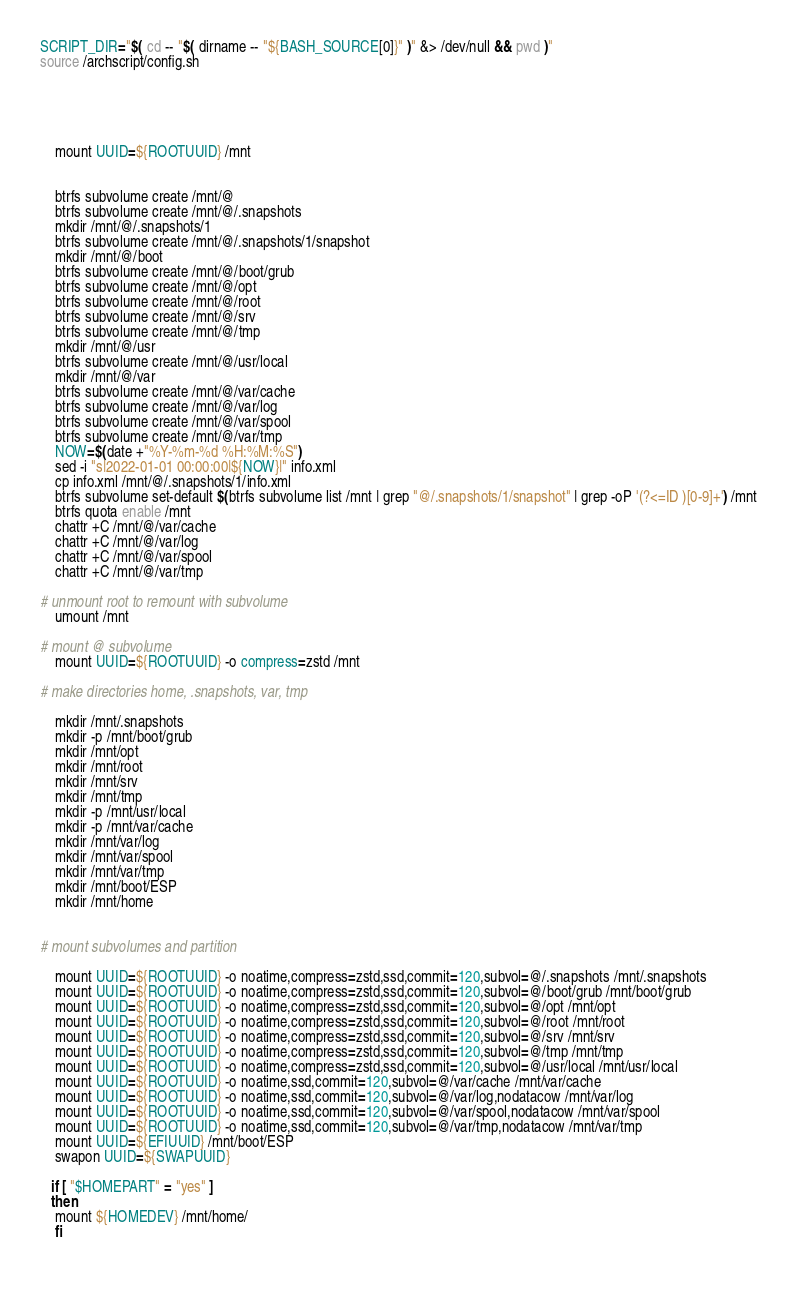<code> <loc_0><loc_0><loc_500><loc_500><_Bash_>SCRIPT_DIR="$( cd -- "$( dirname -- "${BASH_SOURCE[0]}" )" &> /dev/null && pwd )"
source /archscript/config.sh





    mount UUID=${ROOTUUID} /mnt


    btrfs subvolume create /mnt/@
	btrfs subvolume create /mnt/@/.snapshots
	mkdir /mnt/@/.snapshots/1
	btrfs subvolume create /mnt/@/.snapshots/1/snapshot
	mkdir /mnt/@/boot
	btrfs subvolume create /mnt/@/boot/grub
	btrfs subvolume create /mnt/@/opt
	btrfs subvolume create /mnt/@/root
	btrfs subvolume create /mnt/@/srv
	btrfs subvolume create /mnt/@/tmp
	mkdir /mnt/@/usr
	btrfs subvolume create /mnt/@/usr/local
	mkdir /mnt/@/var
	btrfs subvolume create /mnt/@/var/cache
	btrfs subvolume create /mnt/@/var/log
	btrfs subvolume create /mnt/@/var/spool
	btrfs subvolume create /mnt/@/var/tmp
	NOW=$(date +"%Y-%m-%d %H:%M:%S")
	sed -i "s|2022-01-01 00:00:00|${NOW}|" info.xml
	cp info.xml /mnt/@/.snapshots/1/info.xml
  	btrfs subvolume set-default $(btrfs subvolume list /mnt | grep "@/.snapshots/1/snapshot" | grep -oP '(?<=ID )[0-9]+') /mnt
	btrfs quota enable /mnt
	chattr +C /mnt/@/var/cache
	chattr +C /mnt/@/var/log
	chattr +C /mnt/@/var/spool
	chattr +C /mnt/@/var/tmp

# unmount root to remount with subvolume
    umount /mnt

# mount @ subvolume
    mount UUID=${ROOTUUID} -o compress=zstd /mnt

# make directories home, .snapshots, var, tmp

	mkdir /mnt/.snapshots
	mkdir -p /mnt/boot/grub
	mkdir /mnt/opt
	mkdir /mnt/root
	mkdir /mnt/srv
	mkdir /mnt/tmp
	mkdir -p /mnt/usr/local
	mkdir -p /mnt/var/cache
	mkdir /mnt/var/log
	mkdir /mnt/var/spool
	mkdir /mnt/var/tmp
	mkdir /mnt/boot/ESP
	mkdir /mnt/home


# mount subvolumes and partition

    mount UUID=${ROOTUUID} -o noatime,compress=zstd,ssd,commit=120,subvol=@/.snapshots /mnt/.snapshots
    mount UUID=${ROOTUUID} -o noatime,compress=zstd,ssd,commit=120,subvol=@/boot/grub /mnt/boot/grub
    mount UUID=${ROOTUUID} -o noatime,compress=zstd,ssd,commit=120,subvol=@/opt /mnt/opt
    mount UUID=${ROOTUUID} -o noatime,compress=zstd,ssd,commit=120,subvol=@/root /mnt/root
    mount UUID=${ROOTUUID} -o noatime,compress=zstd,ssd,commit=120,subvol=@/srv /mnt/srv
    mount UUID=${ROOTUUID} -o noatime,compress=zstd,ssd,commit=120,subvol=@/tmp /mnt/tmp
    mount UUID=${ROOTUUID} -o noatime,compress=zstd,ssd,commit=120,subvol=@/usr/local /mnt/usr/local
    mount UUID=${ROOTUUID} -o noatime,ssd,commit=120,subvol=@/var/cache /mnt/var/cache
    mount UUID=${ROOTUUID} -o noatime,ssd,commit=120,subvol=@/var/log,nodatacow /mnt/var/log
    mount UUID=${ROOTUUID} -o noatime,ssd,commit=120,subvol=@/var/spool,nodatacow /mnt/var/spool
    mount UUID=${ROOTUUID} -o noatime,ssd,commit=120,subvol=@/var/tmp,nodatacow /mnt/var/tmp
    mount UUID=${EFIUUID} /mnt/boot/ESP
    swapon UUID=${SWAPUUID}
    
   if [ "$HOMEPART" = "yes" ]
   then
    mount ${HOMEDEV} /mnt/home/
    fi 
	



</code> 